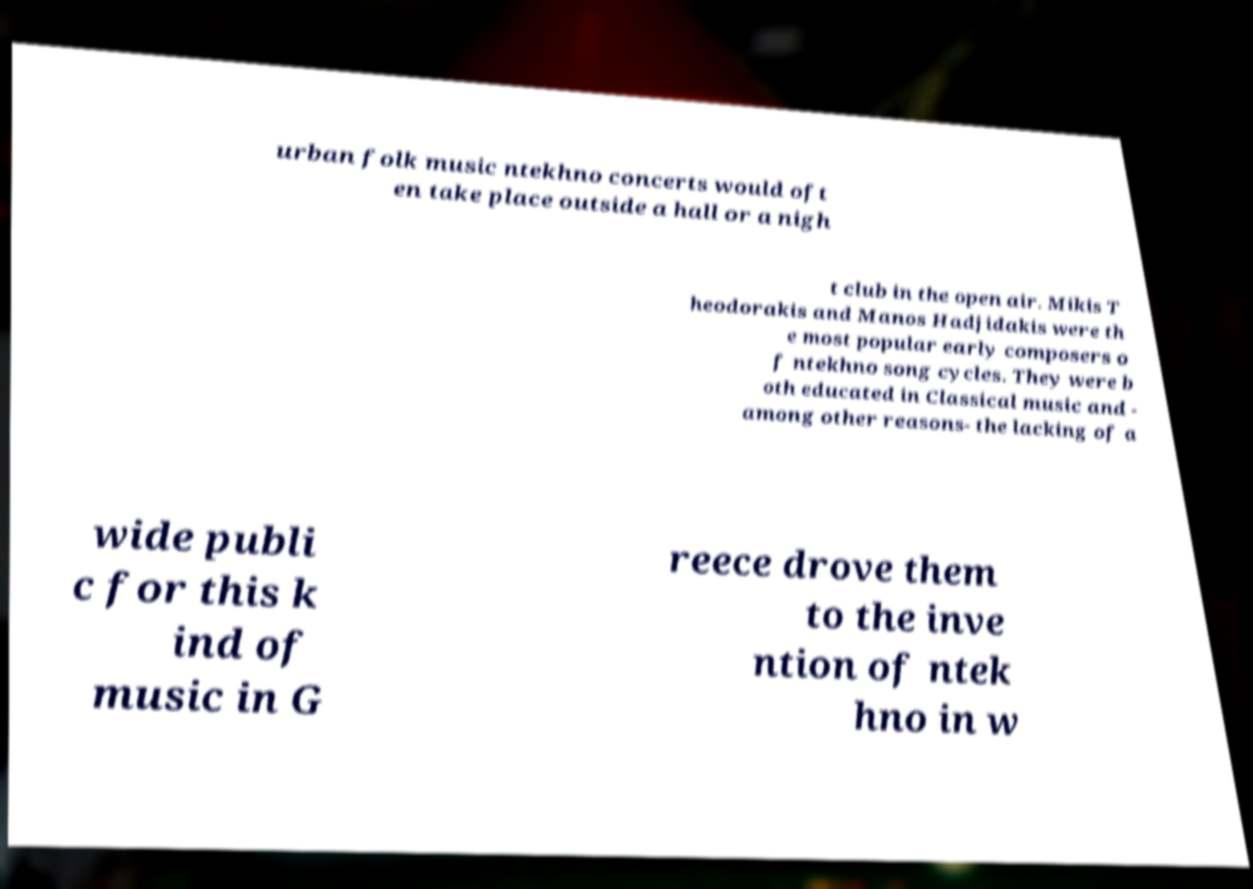What messages or text are displayed in this image? I need them in a readable, typed format. urban folk music ntekhno concerts would oft en take place outside a hall or a nigh t club in the open air. Mikis T heodorakis and Manos Hadjidakis were th e most popular early composers o f ntekhno song cycles. They were b oth educated in Classical music and - among other reasons- the lacking of a wide publi c for this k ind of music in G reece drove them to the inve ntion of ntek hno in w 